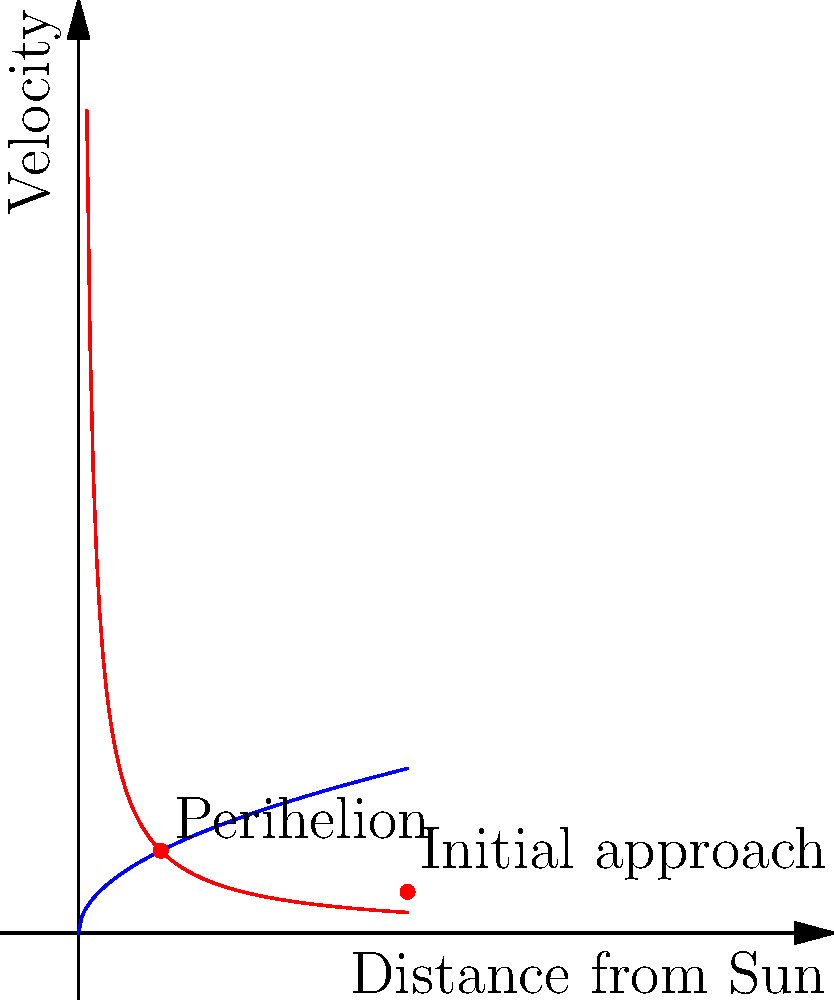As a filmmaker documenting a street performer's journey, you decide to incorporate an astronomical analogy in your narrative. You want to explain the performer's increasing momentum as they approach their big break, similar to a comet's trajectory near the sun. Based on the graph, which shows a comet's velocity as it approaches the sun, what happens to the comet's speed at the point of closest approach (perihelion)? To understand the comet's behavior as it approaches the sun, let's analyze the graph step-by-step:

1. The red curve represents the comet's trajectory, showing its velocity as a function of distance from the sun.

2. The blue curve represents the sun's gravitational influence.

3. As the comet moves from right to left on the graph (approaching the sun), its velocity increases. This is due to the sun's gravitational pull accelerating the comet.

4. The point labeled "Perihelion" represents the comet's closest approach to the sun.

5. At the perihelion point, the velocity curve reaches its peak. This means the comet's speed is at its maximum when it's closest to the sun.

6. After passing the perihelion, the comet's speed would decrease as it moves away from the sun, following the same curve but in the opposite direction.

This behavior is explained by Kepler's Second Law of Planetary Motion, which states that a line segment joining a planet (or comet) and the sun sweeps out equal areas during equal intervals of time. To maintain this equal area, the comet must move faster when it's closer to the sun.

In the context of the filmmaker's analogy, this could represent how the street performer's momentum and energy peak as they reach their "big break" moment, similar to the comet's maximum velocity at perihelion.
Answer: The comet's speed reaches its maximum at perihelion. 